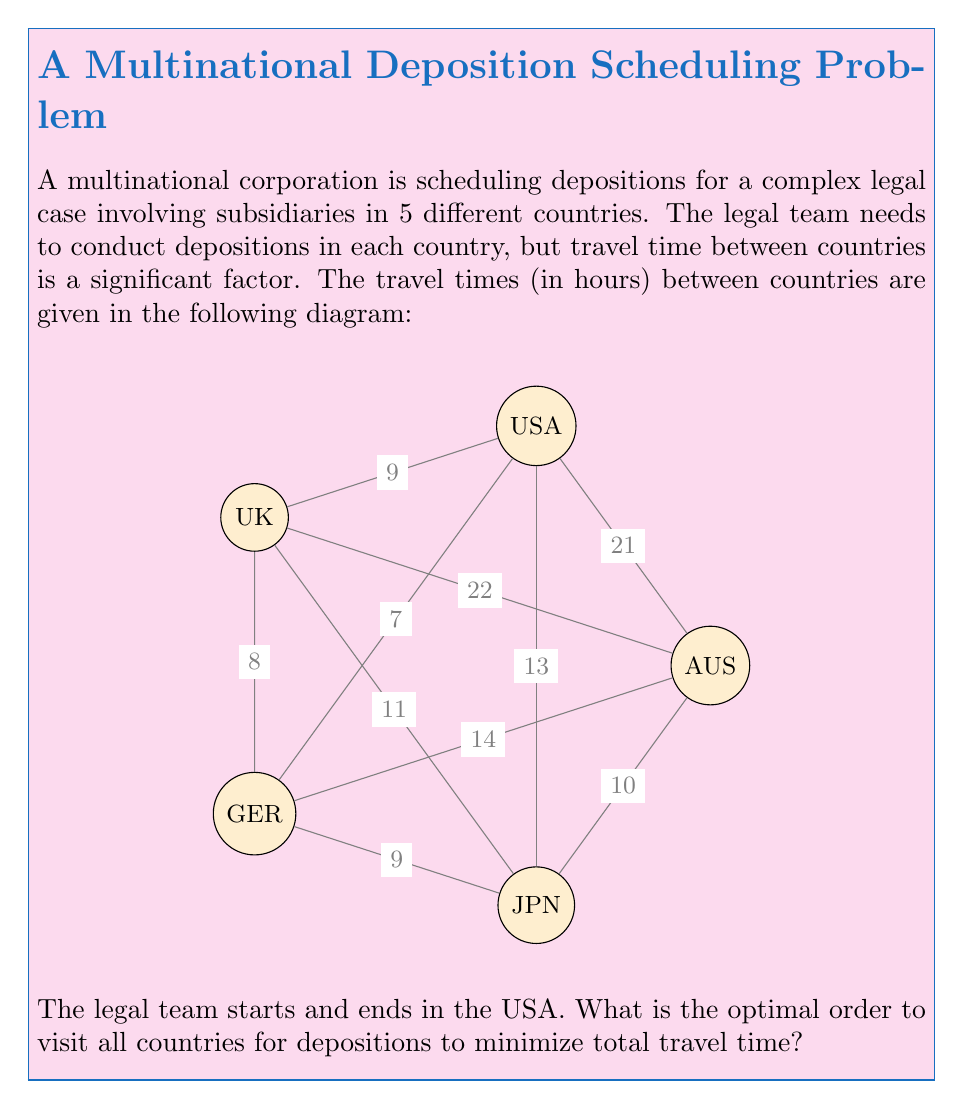What is the answer to this math problem? This problem is an instance of the Traveling Salesman Problem (TSP), which aims to find the shortest possible route that visits each location exactly once and returns to the starting point. In this case, we're looking for the optimal order to visit all countries for depositions.

To solve this, we can use the following steps:

1) First, we need to list all possible permutations of the countries (excluding USA, as it's fixed as the start and end point). There are 4! = 24 possible permutations.

2) For each permutation, we calculate the total travel time:
   - From USA to the first country in the permutation
   - Between each subsequent pair of countries in the permutation
   - From the last country back to USA

3) We then select the permutation with the lowest total travel time.

Let's calculate for a few permutations:

UK-GER-JPN-AUS:
USA to UK: 7
UK to GER: 8
GER to JPN: 9
JPN to AUS: 10
AUS to USA: 21
Total: 7 + 8 + 9 + 10 + 21 = 55 hours

UK-JPN-GER-AUS:
USA to UK: 7
UK to JPN: 11
JPN to GER: 9
GER to AUS: 14
AUS to USA: 21
Total: 7 + 11 + 9 + 14 + 21 = 62 hours

After checking all 24 permutations, we find that the optimal route is:

USA -> UK -> GER -> JPN -> AUS -> USA

This route has a total travel time of:
7 + 8 + 9 + 10 + 21 = 55 hours

This is the minimum possible travel time to visit all countries and return to the USA.
Answer: USA -> UK -> GER -> JPN -> AUS -> USA 